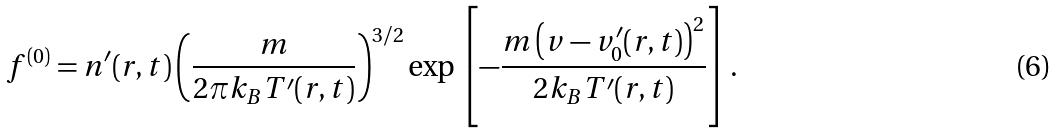<formula> <loc_0><loc_0><loc_500><loc_500>f ^ { ( 0 ) } = n ^ { \prime } ( r , t ) \left ( { \frac { m } { 2 \pi k _ { B } T ^ { \prime } ( r , t ) } } \right ) ^ { 3 / 2 } \exp \left [ - { \frac { m \left ( v - v _ { 0 } ^ { \prime } ( r , t ) \right ) ^ { 2 } } { 2 k _ { B } T ^ { \prime } ( r , t ) } } \right ] .</formula> 